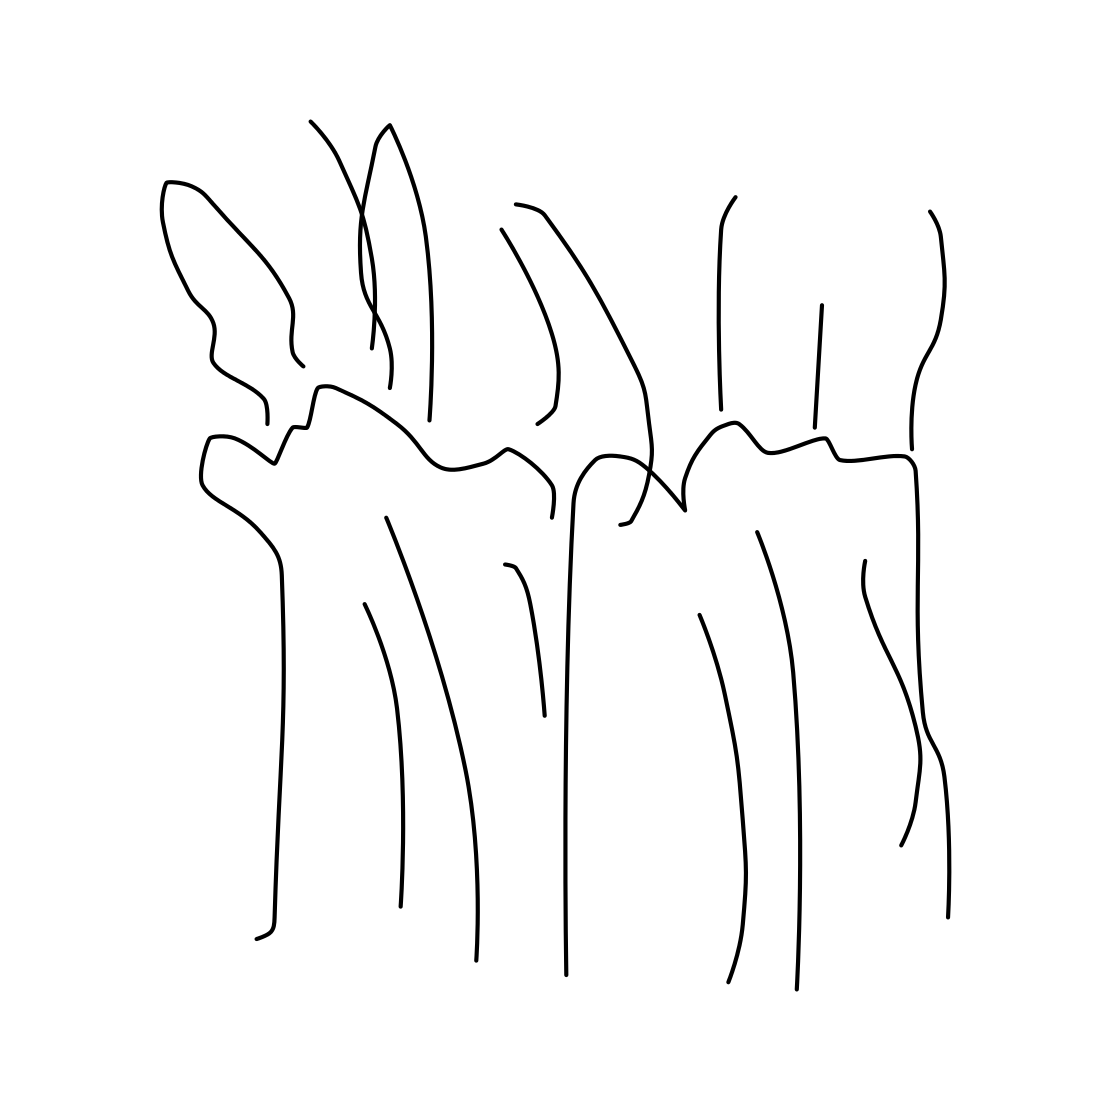Could this image have a specific meaning? While the image is abstract and therefore inherently ambiguous, it is possible that the artist intended to convey a particular theme, such as the interconnectivity of life or the beauty of natural forms. The absence of color and the simplicity of lines could also suggest a focus on the essence of shapes and organic structure. 